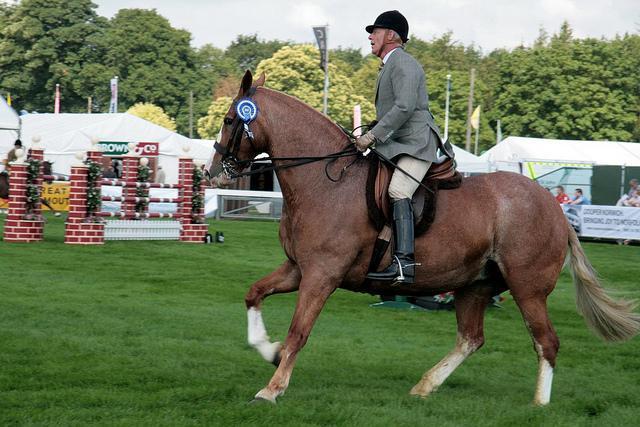How many sinks are there?
Give a very brief answer. 0. 